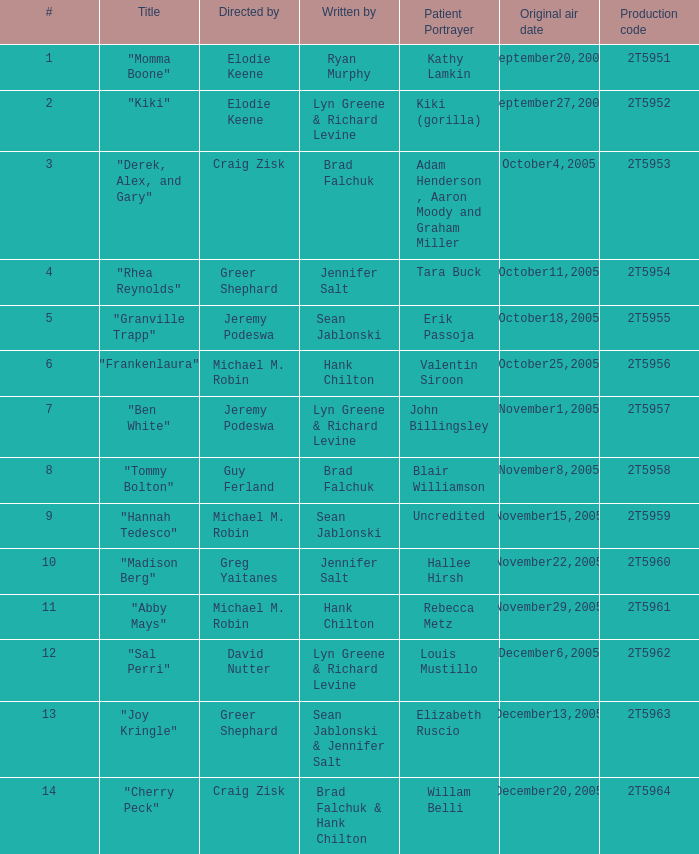Who were the writers for the episode titled "Ben White"? Lyn Greene & Richard Levine. 